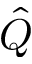<formula> <loc_0><loc_0><loc_500><loc_500>\hat { Q }</formula> 